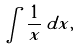Convert formula to latex. <formula><loc_0><loc_0><loc_500><loc_500>\int { \frac { 1 } { x } } \, d x ,</formula> 